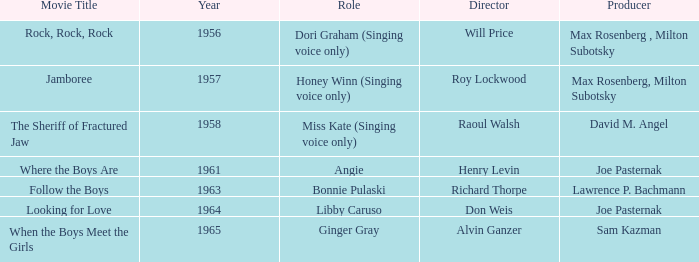What year was Sam Kazman a producer? 1965.0. 